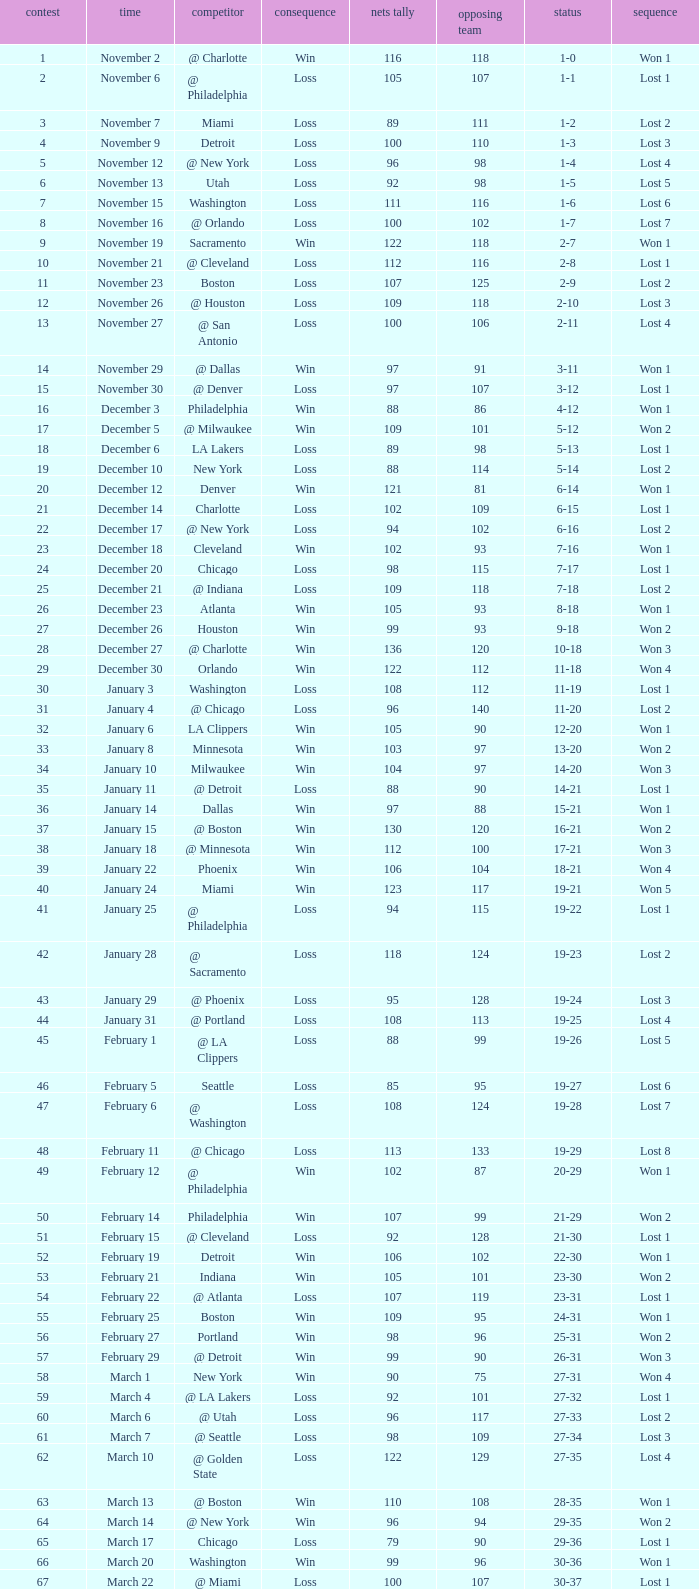Which opponent is from february 12? @ Philadelphia. 